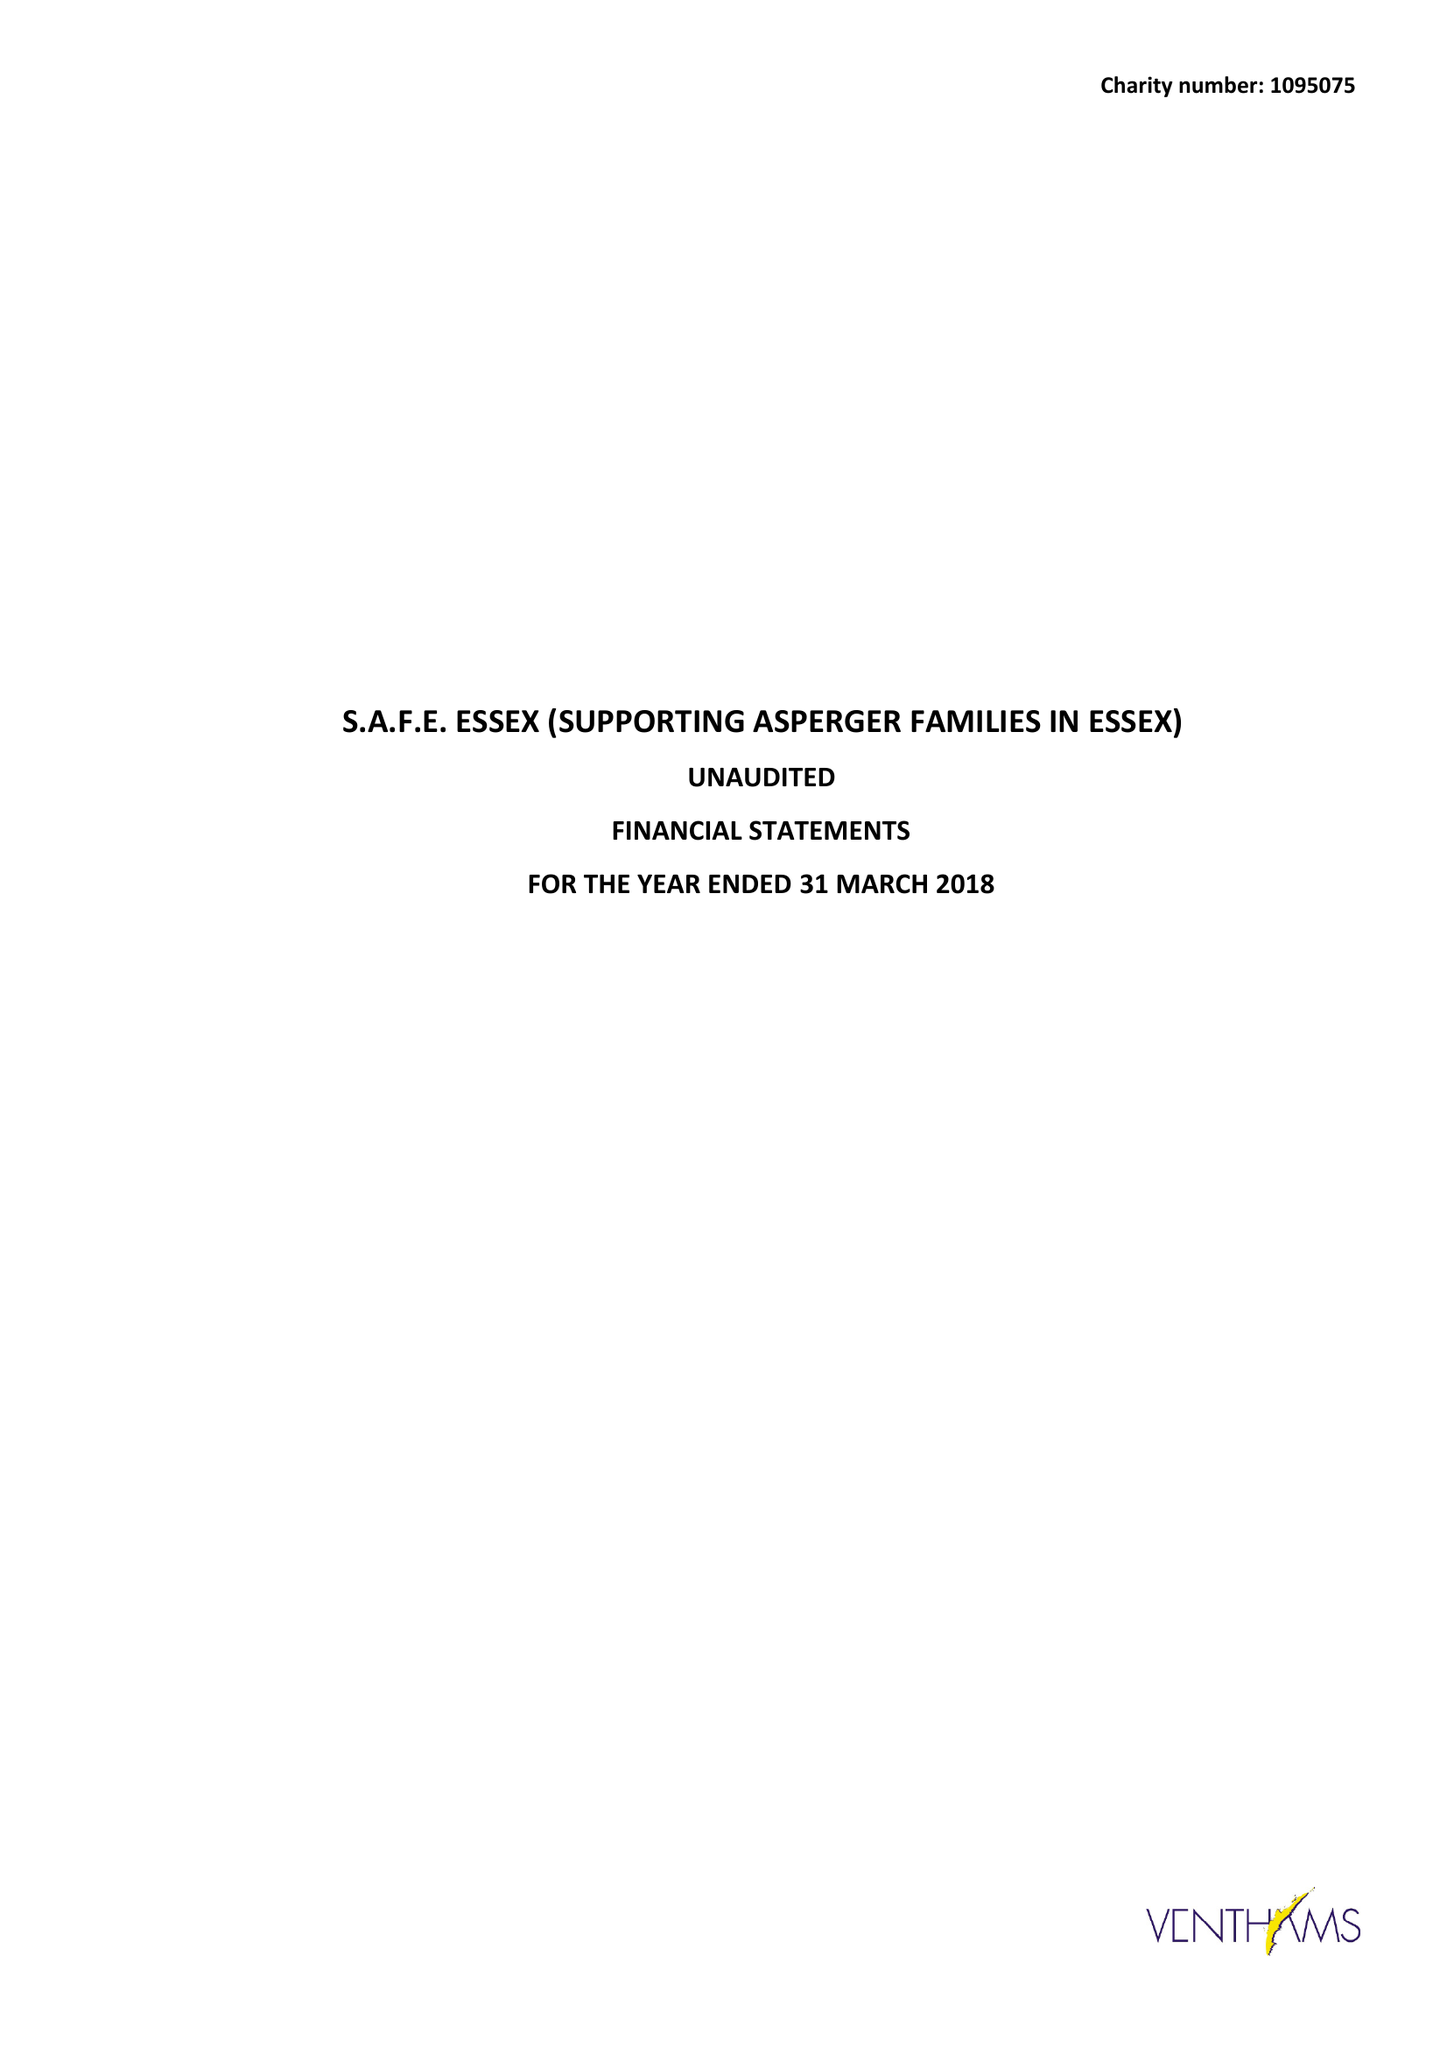What is the value for the address__post_town?
Answer the question using a single word or phrase. WITHAM 